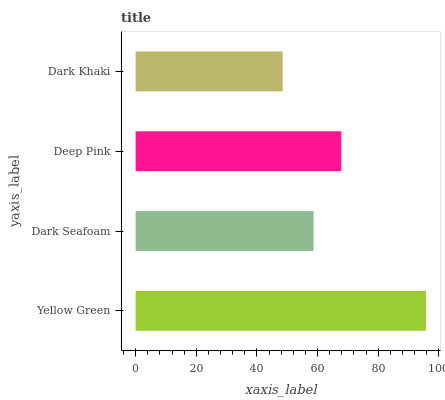Is Dark Khaki the minimum?
Answer yes or no. Yes. Is Yellow Green the maximum?
Answer yes or no. Yes. Is Dark Seafoam the minimum?
Answer yes or no. No. Is Dark Seafoam the maximum?
Answer yes or no. No. Is Yellow Green greater than Dark Seafoam?
Answer yes or no. Yes. Is Dark Seafoam less than Yellow Green?
Answer yes or no. Yes. Is Dark Seafoam greater than Yellow Green?
Answer yes or no. No. Is Yellow Green less than Dark Seafoam?
Answer yes or no. No. Is Deep Pink the high median?
Answer yes or no. Yes. Is Dark Seafoam the low median?
Answer yes or no. Yes. Is Dark Khaki the high median?
Answer yes or no. No. Is Deep Pink the low median?
Answer yes or no. No. 